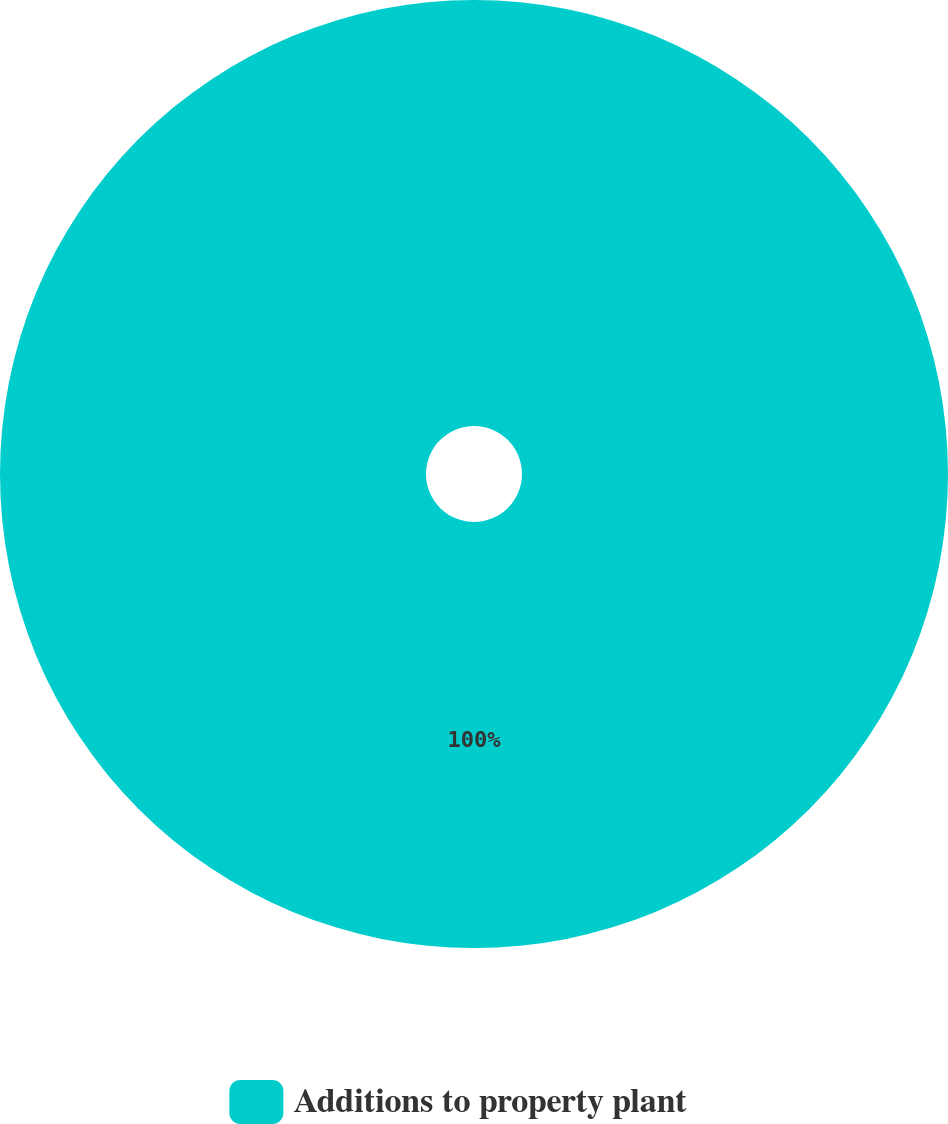Convert chart to OTSL. <chart><loc_0><loc_0><loc_500><loc_500><pie_chart><fcel>Additions to property plant<nl><fcel>100.0%<nl></chart> 